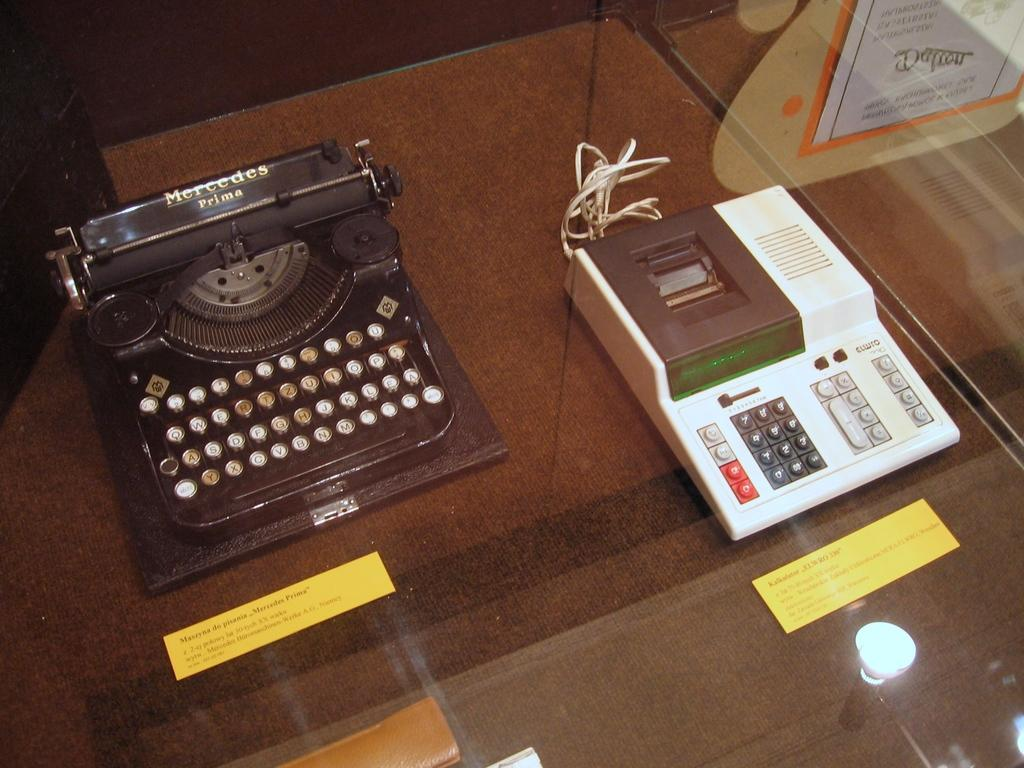Provide a one-sentence caption for the provided image. A Mercedes prima typewriter is displayed on a glass table next to a EL WRO 330 calculator. 